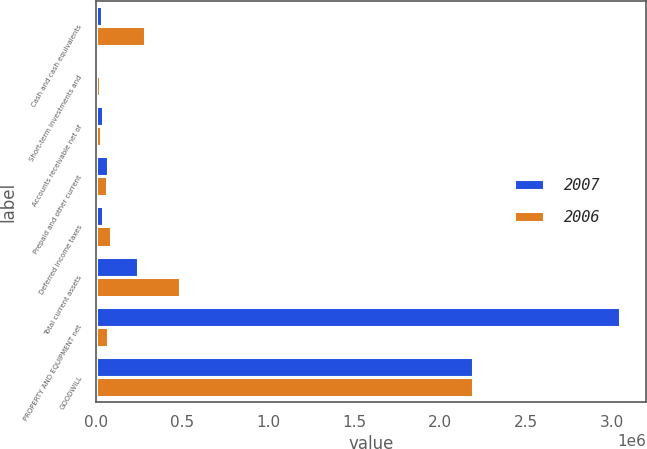Convert chart to OTSL. <chart><loc_0><loc_0><loc_500><loc_500><stacked_bar_chart><ecel><fcel>Cash and cash equivalents<fcel>Short-term investments and<fcel>Accounts receivable net of<fcel>Prepaid and other current<fcel>Deferred income taxes<fcel>Total current assets<fcel>PROPERTY AND EQUIPMENT net<fcel>GOODWILL<nl><fcel>2007<fcel>33123<fcel>7224<fcel>40316<fcel>71264<fcel>40063<fcel>245674<fcel>3.04519e+06<fcel>2.18831e+06<nl><fcel>2006<fcel>281264<fcel>22986<fcel>29368<fcel>63919<fcel>88485<fcel>486022<fcel>71264<fcel>2.18977e+06<nl></chart> 